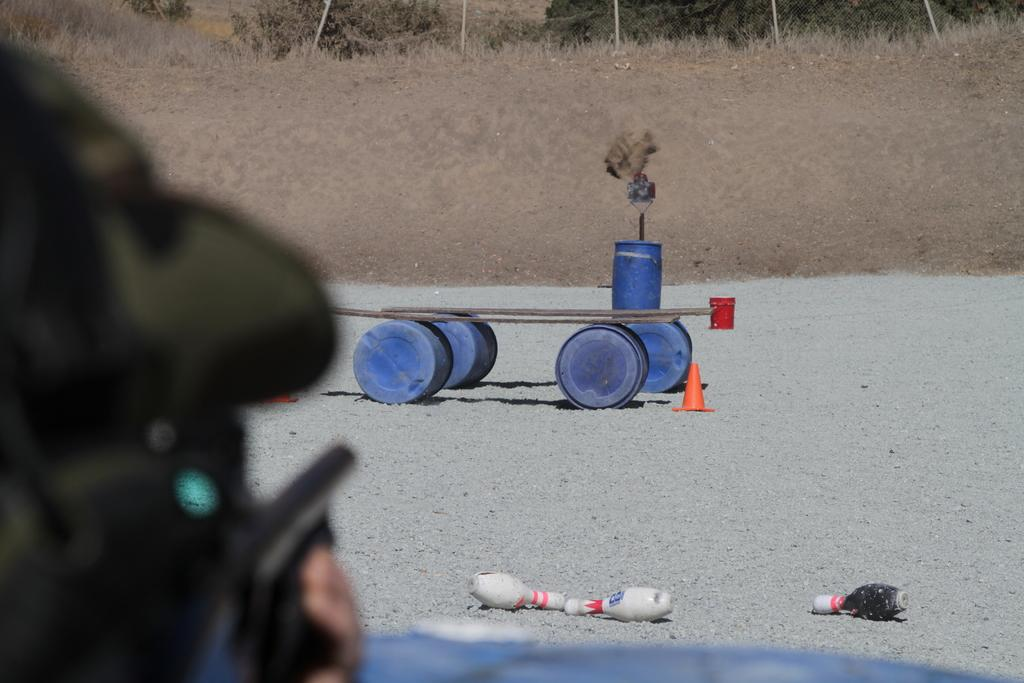What part of a person's body is visible in the image? There is a person's hand in the image. What event or action is depicted in the image? There is a bowling alley strike in the image. What type of terrain or surface is present in the image? There is sand and dry grass in the image. What structures or objects can be seen in the image? There is a pole, a plant, a wooden sheet, and a drum in the image. What is the distance between the drum and the plant in the image? The provided facts do not give information about the distance between the drum and the plant, so it cannot be determined from the image. How does the plant behave in the image? The provided facts do not give information about the behavior of the plant, so it cannot be determined from the image. 